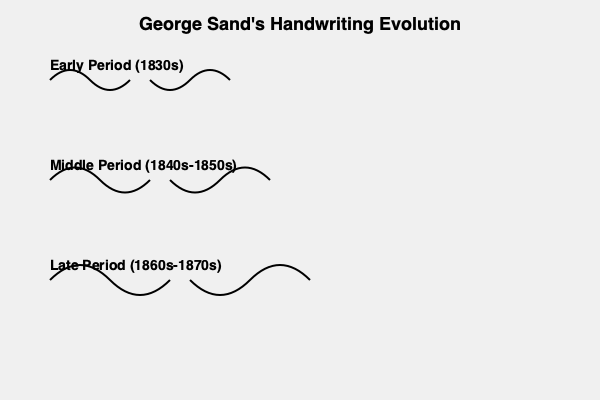Based on the visual representation of George Sand's handwriting evolution, which characteristic change is most evident from the early to the late period? To answer this question, we need to analyze the changes in George Sand's handwriting across the three periods shown:

1. Early Period (1830s):
   - The handwriting appears relatively compact and controlled.
   - The curves are smaller and tighter.
   - The overall style seems more restrained.

2. Middle Period (1840s-1850s):
   - The handwriting shows signs of expansion.
   - The curves become slightly larger and more pronounced.
   - There's a noticeable increase in the spacing between letters.

3. Late Period (1860s-1870s):
   - The handwriting exhibits the most dramatic change.
   - The curves are much larger and more expansive.
   - The overall style appears more flowing and less constrained.

Comparing the early and late periods, the most evident change is the increased size and expansiveness of the handwriting. The curves in the late period are significantly larger and more sweeping than in the early period, indicating a more confident and expressive writing style.

This evolution in handwriting could reflect changes in Sand's writing process, emotional state, or even physical conditions as she aged. It might also indicate a development in her literary style, becoming more fluid and expansive over time.
Answer: Increased size and expansiveness of the handwriting 